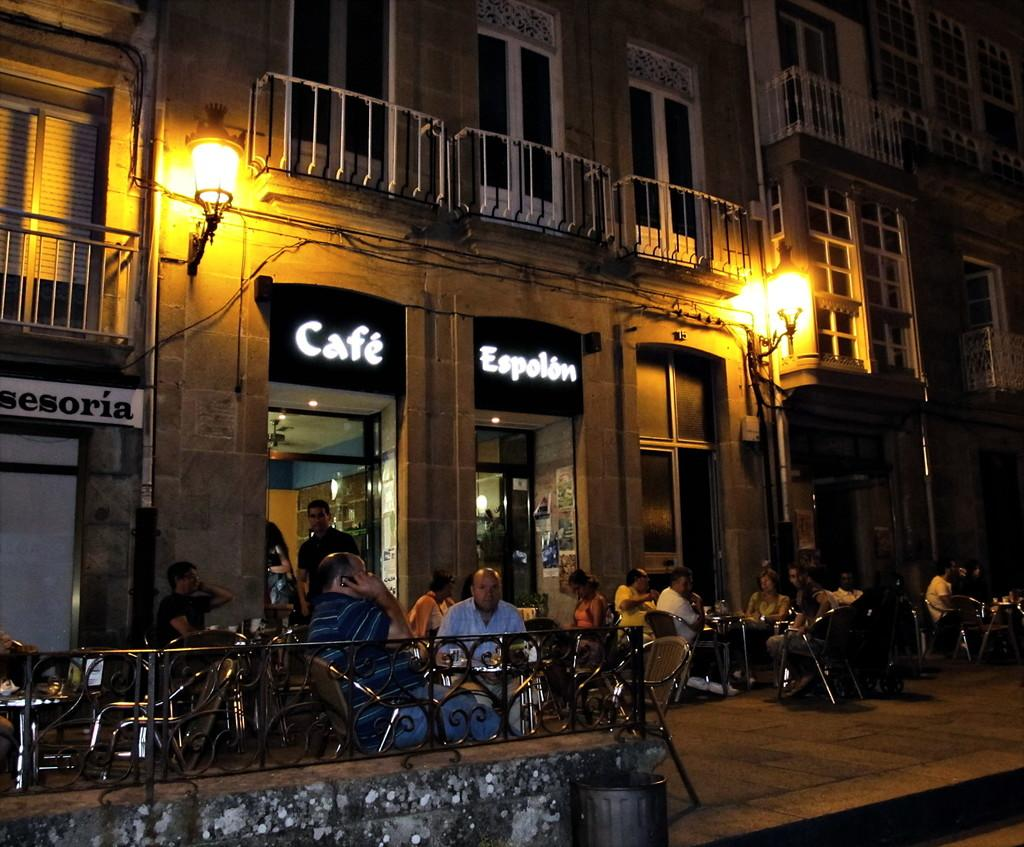<image>
Share a concise interpretation of the image provided. People sit outside Cafe Espolon's brightly illuminated sign. 